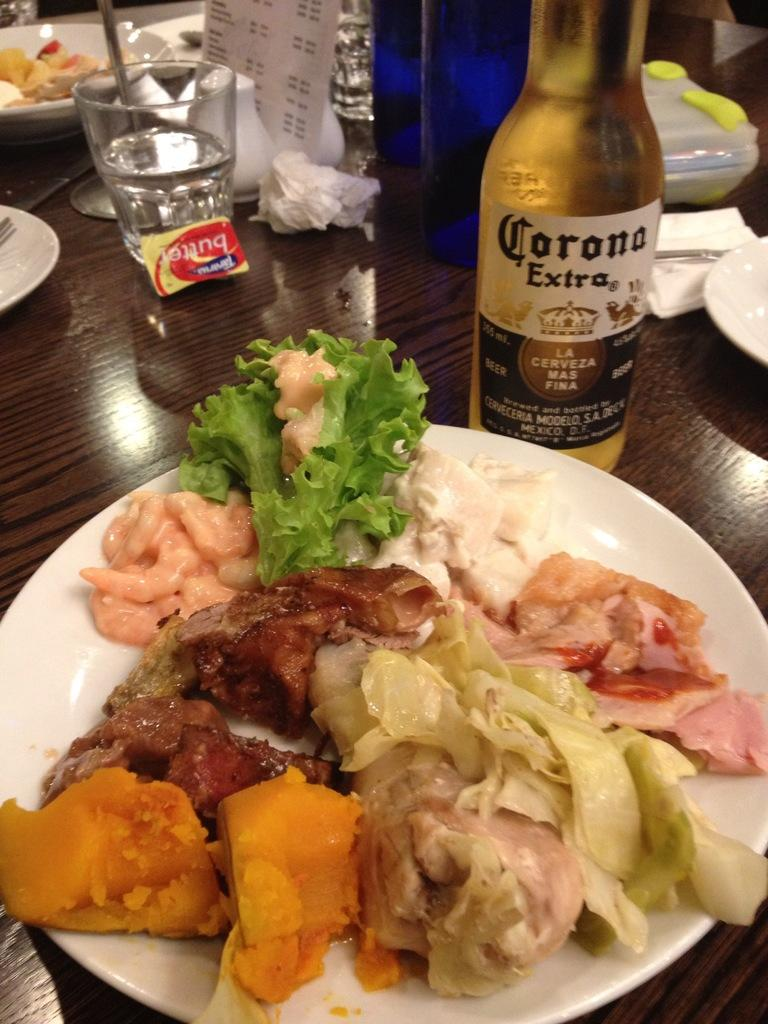<image>
Render a clear and concise summary of the photo. plate of food in front of bottle of corona extra on a table with other plates and glasses 